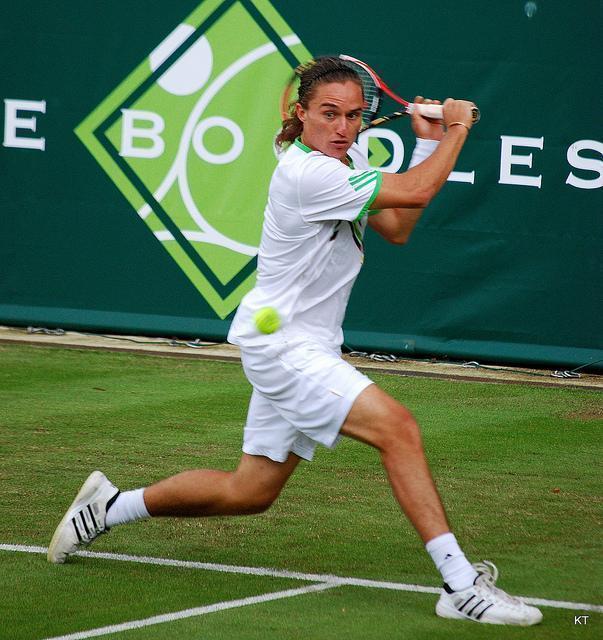What is the color of tennis ball used in earlier days?
Indicate the correct choice and explain in the format: 'Answer: answer
Rationale: rationale.'
Options: Red, white, green, yellow. Answer: yellow.
Rationale: They used to be more yellowish. 